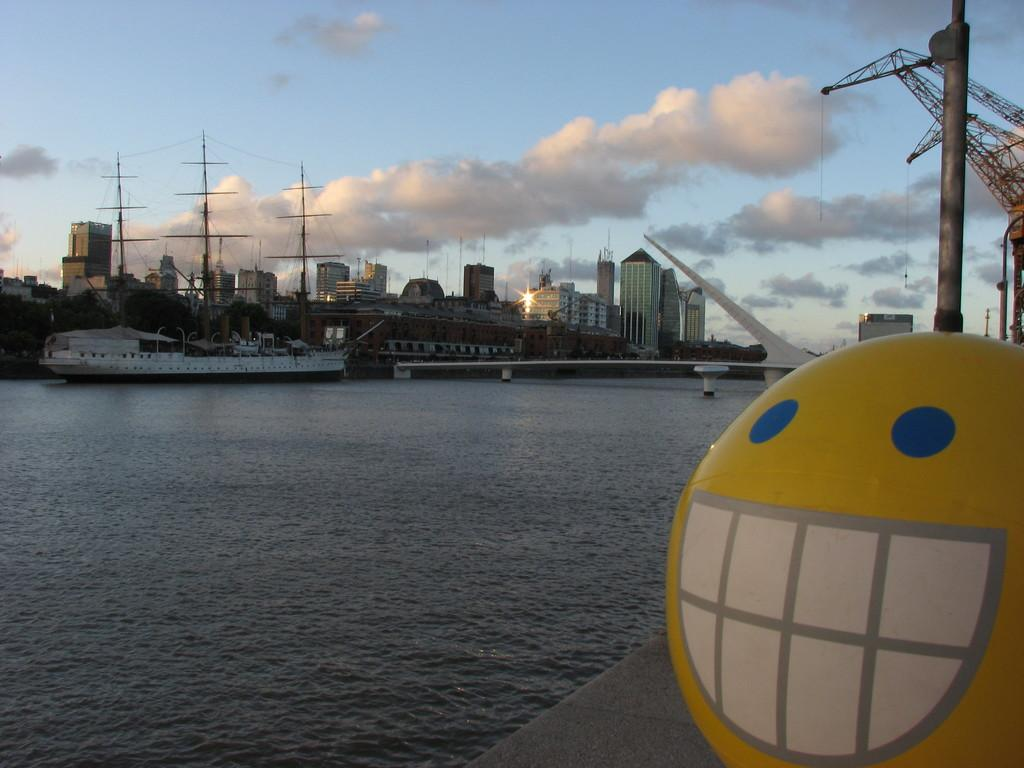What is located at the right side of the image? There is an emoji at the right side of the image. What can be seen in the image besides the emoji? There is water, ships, buildings, and a bridge visible in the image. What is the condition of the sky in the image? The sky is visible in the image, and there are clouds present. What type of debt is being discussed in the lunchroom in the image? There is no lunchroom or discussion of debt present in the image; it features an emoji, water, ships, buildings, and a bridge. What button is being pushed by the person in the image? There is no person or button present in the image. 